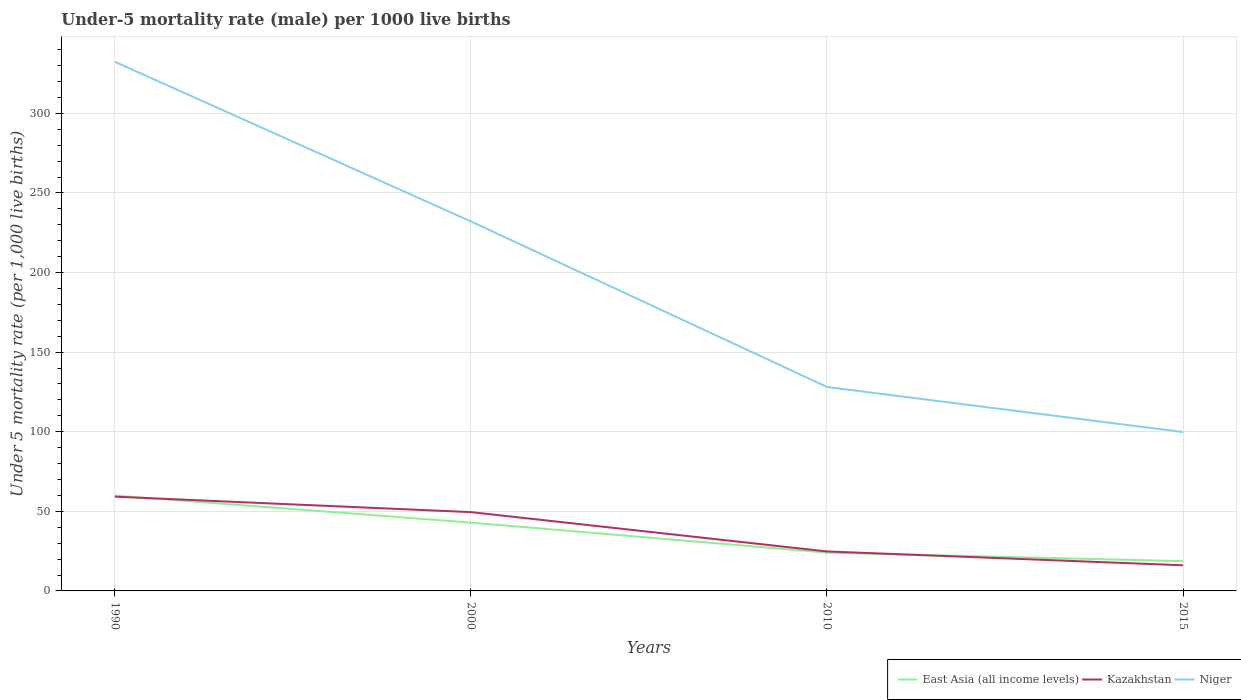How many different coloured lines are there?
Offer a very short reply. 3. Across all years, what is the maximum under-five mortality rate in Niger?
Your response must be concise. 99.8. In which year was the under-five mortality rate in Kazakhstan maximum?
Provide a succinct answer. 2015. What is the total under-five mortality rate in East Asia (all income levels) in the graph?
Make the answer very short. 24.23. What is the difference between the highest and the second highest under-five mortality rate in Kazakhstan?
Keep it short and to the point. 43.1. What is the difference between the highest and the lowest under-five mortality rate in Kazakhstan?
Your answer should be very brief. 2. Is the under-five mortality rate in East Asia (all income levels) strictly greater than the under-five mortality rate in Niger over the years?
Your answer should be compact. Yes. How many lines are there?
Provide a succinct answer. 3. What is the difference between two consecutive major ticks on the Y-axis?
Your response must be concise. 50. Are the values on the major ticks of Y-axis written in scientific E-notation?
Ensure brevity in your answer.  No. Does the graph contain grids?
Your answer should be compact. Yes. Where does the legend appear in the graph?
Provide a succinct answer. Bottom right. How many legend labels are there?
Your response must be concise. 3. How are the legend labels stacked?
Provide a succinct answer. Horizontal. What is the title of the graph?
Keep it short and to the point. Under-5 mortality rate (male) per 1000 live births. What is the label or title of the X-axis?
Your response must be concise. Years. What is the label or title of the Y-axis?
Your answer should be compact. Under 5 mortality rate (per 1,0 live births). What is the Under 5 mortality rate (per 1,000 live births) of East Asia (all income levels) in 1990?
Make the answer very short. 59.91. What is the Under 5 mortality rate (per 1,000 live births) in Kazakhstan in 1990?
Keep it short and to the point. 59.2. What is the Under 5 mortality rate (per 1,000 live births) in Niger in 1990?
Your answer should be very brief. 332.4. What is the Under 5 mortality rate (per 1,000 live births) in East Asia (all income levels) in 2000?
Offer a very short reply. 42.92. What is the Under 5 mortality rate (per 1,000 live births) of Kazakhstan in 2000?
Provide a short and direct response. 49.5. What is the Under 5 mortality rate (per 1,000 live births) in Niger in 2000?
Give a very brief answer. 232.1. What is the Under 5 mortality rate (per 1,000 live births) of East Asia (all income levels) in 2010?
Make the answer very short. 24.06. What is the Under 5 mortality rate (per 1,000 live births) of Kazakhstan in 2010?
Your answer should be very brief. 24.8. What is the Under 5 mortality rate (per 1,000 live births) of Niger in 2010?
Your response must be concise. 128.1. What is the Under 5 mortality rate (per 1,000 live births) in East Asia (all income levels) in 2015?
Make the answer very short. 18.69. What is the Under 5 mortality rate (per 1,000 live births) in Niger in 2015?
Your response must be concise. 99.8. Across all years, what is the maximum Under 5 mortality rate (per 1,000 live births) of East Asia (all income levels)?
Offer a very short reply. 59.91. Across all years, what is the maximum Under 5 mortality rate (per 1,000 live births) of Kazakhstan?
Your answer should be compact. 59.2. Across all years, what is the maximum Under 5 mortality rate (per 1,000 live births) in Niger?
Provide a succinct answer. 332.4. Across all years, what is the minimum Under 5 mortality rate (per 1,000 live births) in East Asia (all income levels)?
Offer a very short reply. 18.69. Across all years, what is the minimum Under 5 mortality rate (per 1,000 live births) in Kazakhstan?
Provide a succinct answer. 16.1. Across all years, what is the minimum Under 5 mortality rate (per 1,000 live births) in Niger?
Your response must be concise. 99.8. What is the total Under 5 mortality rate (per 1,000 live births) of East Asia (all income levels) in the graph?
Give a very brief answer. 145.58. What is the total Under 5 mortality rate (per 1,000 live births) of Kazakhstan in the graph?
Your answer should be compact. 149.6. What is the total Under 5 mortality rate (per 1,000 live births) in Niger in the graph?
Give a very brief answer. 792.4. What is the difference between the Under 5 mortality rate (per 1,000 live births) of East Asia (all income levels) in 1990 and that in 2000?
Ensure brevity in your answer.  16.99. What is the difference between the Under 5 mortality rate (per 1,000 live births) in Niger in 1990 and that in 2000?
Provide a short and direct response. 100.3. What is the difference between the Under 5 mortality rate (per 1,000 live births) in East Asia (all income levels) in 1990 and that in 2010?
Give a very brief answer. 35.85. What is the difference between the Under 5 mortality rate (per 1,000 live births) of Kazakhstan in 1990 and that in 2010?
Make the answer very short. 34.4. What is the difference between the Under 5 mortality rate (per 1,000 live births) in Niger in 1990 and that in 2010?
Provide a succinct answer. 204.3. What is the difference between the Under 5 mortality rate (per 1,000 live births) of East Asia (all income levels) in 1990 and that in 2015?
Ensure brevity in your answer.  41.22. What is the difference between the Under 5 mortality rate (per 1,000 live births) of Kazakhstan in 1990 and that in 2015?
Offer a terse response. 43.1. What is the difference between the Under 5 mortality rate (per 1,000 live births) in Niger in 1990 and that in 2015?
Offer a terse response. 232.6. What is the difference between the Under 5 mortality rate (per 1,000 live births) of East Asia (all income levels) in 2000 and that in 2010?
Give a very brief answer. 18.86. What is the difference between the Under 5 mortality rate (per 1,000 live births) of Kazakhstan in 2000 and that in 2010?
Ensure brevity in your answer.  24.7. What is the difference between the Under 5 mortality rate (per 1,000 live births) of Niger in 2000 and that in 2010?
Your response must be concise. 104. What is the difference between the Under 5 mortality rate (per 1,000 live births) in East Asia (all income levels) in 2000 and that in 2015?
Offer a very short reply. 24.23. What is the difference between the Under 5 mortality rate (per 1,000 live births) in Kazakhstan in 2000 and that in 2015?
Your response must be concise. 33.4. What is the difference between the Under 5 mortality rate (per 1,000 live births) in Niger in 2000 and that in 2015?
Give a very brief answer. 132.3. What is the difference between the Under 5 mortality rate (per 1,000 live births) in East Asia (all income levels) in 2010 and that in 2015?
Offer a terse response. 5.37. What is the difference between the Under 5 mortality rate (per 1,000 live births) in Kazakhstan in 2010 and that in 2015?
Provide a succinct answer. 8.7. What is the difference between the Under 5 mortality rate (per 1,000 live births) of Niger in 2010 and that in 2015?
Keep it short and to the point. 28.3. What is the difference between the Under 5 mortality rate (per 1,000 live births) in East Asia (all income levels) in 1990 and the Under 5 mortality rate (per 1,000 live births) in Kazakhstan in 2000?
Provide a succinct answer. 10.41. What is the difference between the Under 5 mortality rate (per 1,000 live births) of East Asia (all income levels) in 1990 and the Under 5 mortality rate (per 1,000 live births) of Niger in 2000?
Make the answer very short. -172.19. What is the difference between the Under 5 mortality rate (per 1,000 live births) of Kazakhstan in 1990 and the Under 5 mortality rate (per 1,000 live births) of Niger in 2000?
Provide a succinct answer. -172.9. What is the difference between the Under 5 mortality rate (per 1,000 live births) of East Asia (all income levels) in 1990 and the Under 5 mortality rate (per 1,000 live births) of Kazakhstan in 2010?
Offer a terse response. 35.11. What is the difference between the Under 5 mortality rate (per 1,000 live births) of East Asia (all income levels) in 1990 and the Under 5 mortality rate (per 1,000 live births) of Niger in 2010?
Make the answer very short. -68.19. What is the difference between the Under 5 mortality rate (per 1,000 live births) of Kazakhstan in 1990 and the Under 5 mortality rate (per 1,000 live births) of Niger in 2010?
Ensure brevity in your answer.  -68.9. What is the difference between the Under 5 mortality rate (per 1,000 live births) in East Asia (all income levels) in 1990 and the Under 5 mortality rate (per 1,000 live births) in Kazakhstan in 2015?
Ensure brevity in your answer.  43.81. What is the difference between the Under 5 mortality rate (per 1,000 live births) in East Asia (all income levels) in 1990 and the Under 5 mortality rate (per 1,000 live births) in Niger in 2015?
Offer a terse response. -39.89. What is the difference between the Under 5 mortality rate (per 1,000 live births) of Kazakhstan in 1990 and the Under 5 mortality rate (per 1,000 live births) of Niger in 2015?
Ensure brevity in your answer.  -40.6. What is the difference between the Under 5 mortality rate (per 1,000 live births) of East Asia (all income levels) in 2000 and the Under 5 mortality rate (per 1,000 live births) of Kazakhstan in 2010?
Your response must be concise. 18.12. What is the difference between the Under 5 mortality rate (per 1,000 live births) in East Asia (all income levels) in 2000 and the Under 5 mortality rate (per 1,000 live births) in Niger in 2010?
Your answer should be compact. -85.18. What is the difference between the Under 5 mortality rate (per 1,000 live births) of Kazakhstan in 2000 and the Under 5 mortality rate (per 1,000 live births) of Niger in 2010?
Keep it short and to the point. -78.6. What is the difference between the Under 5 mortality rate (per 1,000 live births) of East Asia (all income levels) in 2000 and the Under 5 mortality rate (per 1,000 live births) of Kazakhstan in 2015?
Keep it short and to the point. 26.82. What is the difference between the Under 5 mortality rate (per 1,000 live births) in East Asia (all income levels) in 2000 and the Under 5 mortality rate (per 1,000 live births) in Niger in 2015?
Make the answer very short. -56.88. What is the difference between the Under 5 mortality rate (per 1,000 live births) of Kazakhstan in 2000 and the Under 5 mortality rate (per 1,000 live births) of Niger in 2015?
Keep it short and to the point. -50.3. What is the difference between the Under 5 mortality rate (per 1,000 live births) of East Asia (all income levels) in 2010 and the Under 5 mortality rate (per 1,000 live births) of Kazakhstan in 2015?
Give a very brief answer. 7.96. What is the difference between the Under 5 mortality rate (per 1,000 live births) in East Asia (all income levels) in 2010 and the Under 5 mortality rate (per 1,000 live births) in Niger in 2015?
Keep it short and to the point. -75.74. What is the difference between the Under 5 mortality rate (per 1,000 live births) in Kazakhstan in 2010 and the Under 5 mortality rate (per 1,000 live births) in Niger in 2015?
Provide a succinct answer. -75. What is the average Under 5 mortality rate (per 1,000 live births) of East Asia (all income levels) per year?
Your response must be concise. 36.39. What is the average Under 5 mortality rate (per 1,000 live births) of Kazakhstan per year?
Your response must be concise. 37.4. What is the average Under 5 mortality rate (per 1,000 live births) of Niger per year?
Give a very brief answer. 198.1. In the year 1990, what is the difference between the Under 5 mortality rate (per 1,000 live births) in East Asia (all income levels) and Under 5 mortality rate (per 1,000 live births) in Kazakhstan?
Ensure brevity in your answer.  0.71. In the year 1990, what is the difference between the Under 5 mortality rate (per 1,000 live births) in East Asia (all income levels) and Under 5 mortality rate (per 1,000 live births) in Niger?
Your response must be concise. -272.49. In the year 1990, what is the difference between the Under 5 mortality rate (per 1,000 live births) in Kazakhstan and Under 5 mortality rate (per 1,000 live births) in Niger?
Your answer should be compact. -273.2. In the year 2000, what is the difference between the Under 5 mortality rate (per 1,000 live births) in East Asia (all income levels) and Under 5 mortality rate (per 1,000 live births) in Kazakhstan?
Your answer should be very brief. -6.58. In the year 2000, what is the difference between the Under 5 mortality rate (per 1,000 live births) in East Asia (all income levels) and Under 5 mortality rate (per 1,000 live births) in Niger?
Make the answer very short. -189.18. In the year 2000, what is the difference between the Under 5 mortality rate (per 1,000 live births) in Kazakhstan and Under 5 mortality rate (per 1,000 live births) in Niger?
Provide a succinct answer. -182.6. In the year 2010, what is the difference between the Under 5 mortality rate (per 1,000 live births) of East Asia (all income levels) and Under 5 mortality rate (per 1,000 live births) of Kazakhstan?
Make the answer very short. -0.74. In the year 2010, what is the difference between the Under 5 mortality rate (per 1,000 live births) in East Asia (all income levels) and Under 5 mortality rate (per 1,000 live births) in Niger?
Offer a terse response. -104.04. In the year 2010, what is the difference between the Under 5 mortality rate (per 1,000 live births) in Kazakhstan and Under 5 mortality rate (per 1,000 live births) in Niger?
Provide a short and direct response. -103.3. In the year 2015, what is the difference between the Under 5 mortality rate (per 1,000 live births) in East Asia (all income levels) and Under 5 mortality rate (per 1,000 live births) in Kazakhstan?
Provide a short and direct response. 2.59. In the year 2015, what is the difference between the Under 5 mortality rate (per 1,000 live births) in East Asia (all income levels) and Under 5 mortality rate (per 1,000 live births) in Niger?
Your answer should be very brief. -81.11. In the year 2015, what is the difference between the Under 5 mortality rate (per 1,000 live births) in Kazakhstan and Under 5 mortality rate (per 1,000 live births) in Niger?
Give a very brief answer. -83.7. What is the ratio of the Under 5 mortality rate (per 1,000 live births) of East Asia (all income levels) in 1990 to that in 2000?
Give a very brief answer. 1.4. What is the ratio of the Under 5 mortality rate (per 1,000 live births) of Kazakhstan in 1990 to that in 2000?
Provide a succinct answer. 1.2. What is the ratio of the Under 5 mortality rate (per 1,000 live births) in Niger in 1990 to that in 2000?
Provide a short and direct response. 1.43. What is the ratio of the Under 5 mortality rate (per 1,000 live births) of East Asia (all income levels) in 1990 to that in 2010?
Offer a very short reply. 2.49. What is the ratio of the Under 5 mortality rate (per 1,000 live births) in Kazakhstan in 1990 to that in 2010?
Your answer should be compact. 2.39. What is the ratio of the Under 5 mortality rate (per 1,000 live births) in Niger in 1990 to that in 2010?
Offer a very short reply. 2.59. What is the ratio of the Under 5 mortality rate (per 1,000 live births) of East Asia (all income levels) in 1990 to that in 2015?
Ensure brevity in your answer.  3.21. What is the ratio of the Under 5 mortality rate (per 1,000 live births) in Kazakhstan in 1990 to that in 2015?
Your answer should be compact. 3.68. What is the ratio of the Under 5 mortality rate (per 1,000 live births) in Niger in 1990 to that in 2015?
Offer a terse response. 3.33. What is the ratio of the Under 5 mortality rate (per 1,000 live births) in East Asia (all income levels) in 2000 to that in 2010?
Your answer should be compact. 1.78. What is the ratio of the Under 5 mortality rate (per 1,000 live births) in Kazakhstan in 2000 to that in 2010?
Give a very brief answer. 2. What is the ratio of the Under 5 mortality rate (per 1,000 live births) of Niger in 2000 to that in 2010?
Offer a terse response. 1.81. What is the ratio of the Under 5 mortality rate (per 1,000 live births) in East Asia (all income levels) in 2000 to that in 2015?
Offer a terse response. 2.3. What is the ratio of the Under 5 mortality rate (per 1,000 live births) in Kazakhstan in 2000 to that in 2015?
Ensure brevity in your answer.  3.07. What is the ratio of the Under 5 mortality rate (per 1,000 live births) of Niger in 2000 to that in 2015?
Offer a terse response. 2.33. What is the ratio of the Under 5 mortality rate (per 1,000 live births) of East Asia (all income levels) in 2010 to that in 2015?
Give a very brief answer. 1.29. What is the ratio of the Under 5 mortality rate (per 1,000 live births) of Kazakhstan in 2010 to that in 2015?
Offer a very short reply. 1.54. What is the ratio of the Under 5 mortality rate (per 1,000 live births) of Niger in 2010 to that in 2015?
Your answer should be very brief. 1.28. What is the difference between the highest and the second highest Under 5 mortality rate (per 1,000 live births) of East Asia (all income levels)?
Keep it short and to the point. 16.99. What is the difference between the highest and the second highest Under 5 mortality rate (per 1,000 live births) in Kazakhstan?
Ensure brevity in your answer.  9.7. What is the difference between the highest and the second highest Under 5 mortality rate (per 1,000 live births) in Niger?
Keep it short and to the point. 100.3. What is the difference between the highest and the lowest Under 5 mortality rate (per 1,000 live births) of East Asia (all income levels)?
Provide a short and direct response. 41.22. What is the difference between the highest and the lowest Under 5 mortality rate (per 1,000 live births) of Kazakhstan?
Offer a very short reply. 43.1. What is the difference between the highest and the lowest Under 5 mortality rate (per 1,000 live births) in Niger?
Your answer should be compact. 232.6. 